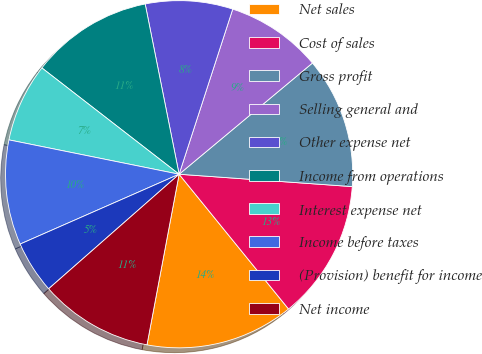<chart> <loc_0><loc_0><loc_500><loc_500><pie_chart><fcel>Net sales<fcel>Cost of sales<fcel>Gross profit<fcel>Selling general and<fcel>Other expense net<fcel>Income from operations<fcel>Interest expense net<fcel>Income before taxes<fcel>(Provision) benefit for income<fcel>Net income<nl><fcel>13.82%<fcel>13.01%<fcel>12.2%<fcel>8.94%<fcel>8.13%<fcel>11.38%<fcel>7.32%<fcel>9.76%<fcel>4.88%<fcel>10.57%<nl></chart> 